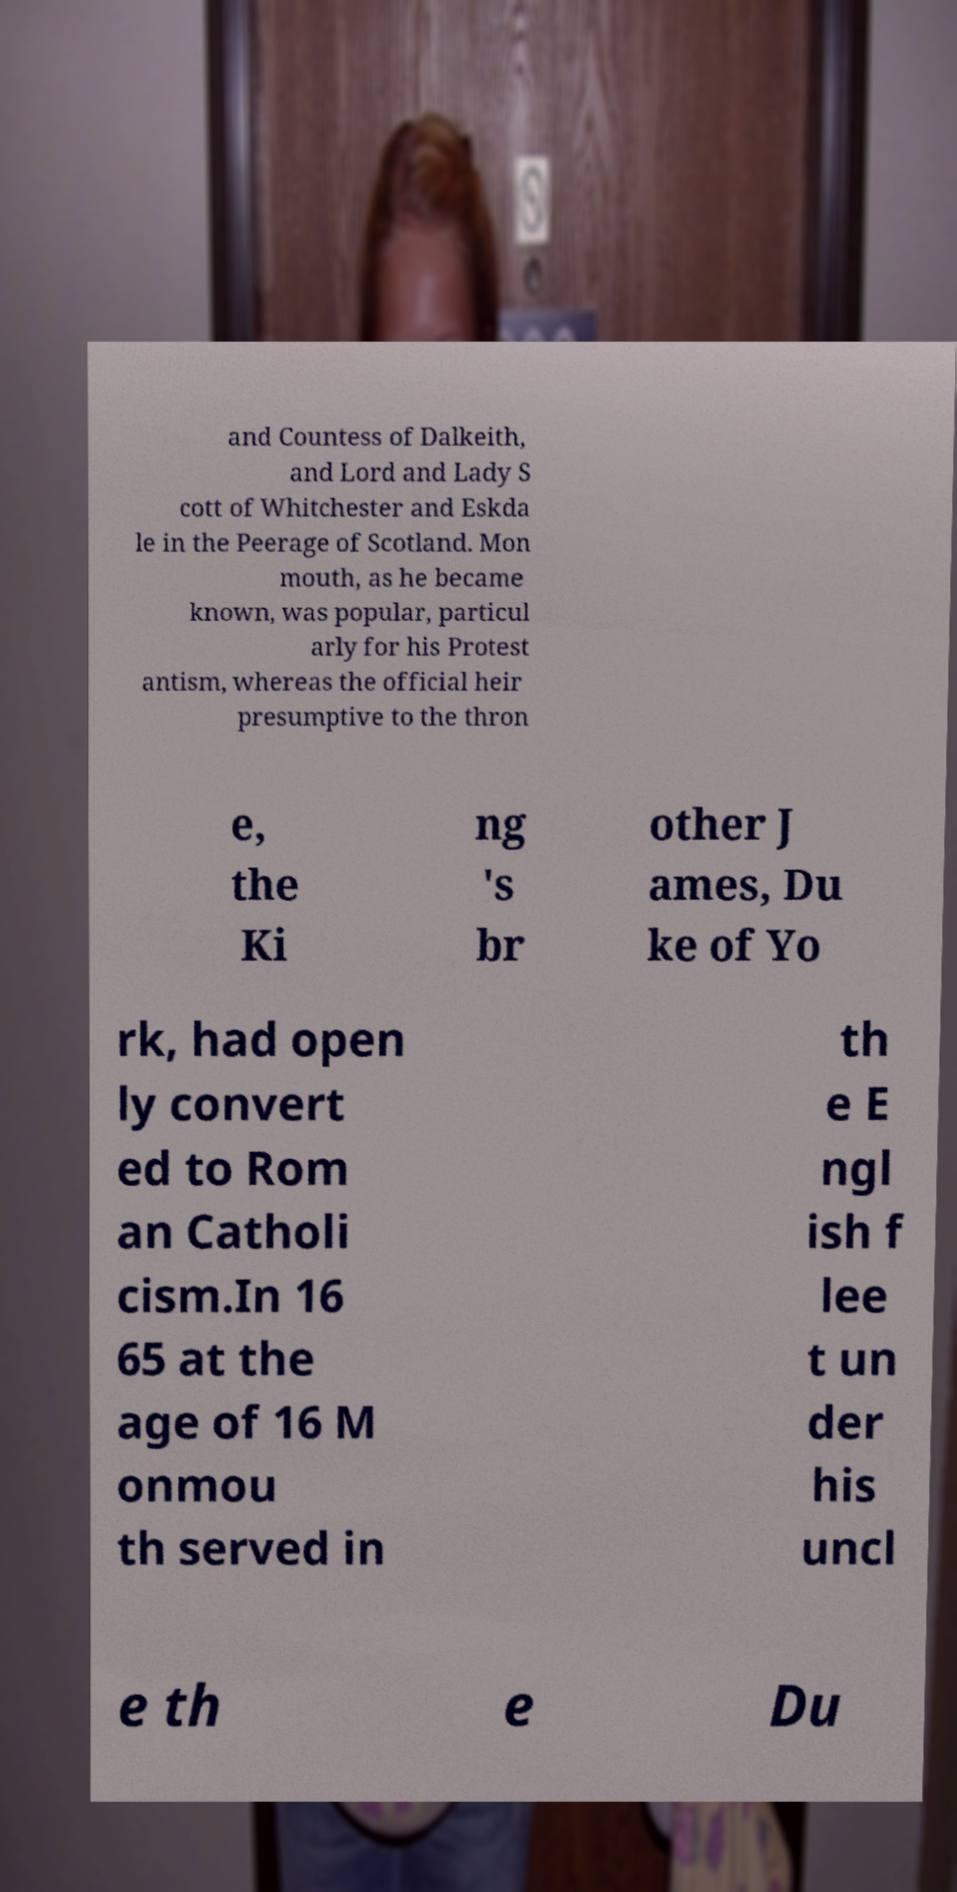I need the written content from this picture converted into text. Can you do that? and Countess of Dalkeith, and Lord and Lady S cott of Whitchester and Eskda le in the Peerage of Scotland. Mon mouth, as he became known, was popular, particul arly for his Protest antism, whereas the official heir presumptive to the thron e, the Ki ng 's br other J ames, Du ke of Yo rk, had open ly convert ed to Rom an Catholi cism.In 16 65 at the age of 16 M onmou th served in th e E ngl ish f lee t un der his uncl e th e Du 